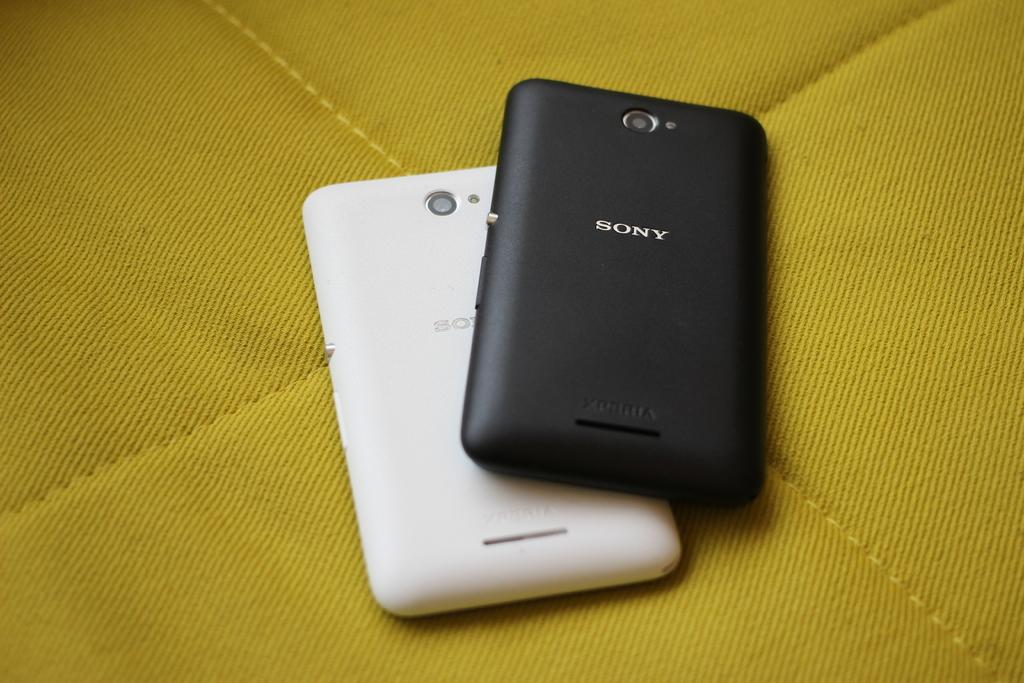<image>
Create a compact narrative representing the image presented. a white and a black sony phone placed ontop of a yellow background 